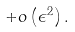<formula> <loc_0><loc_0><loc_500><loc_500>+ o \left ( \epsilon ^ { 2 } \right ) .</formula> 